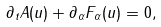<formula> <loc_0><loc_0><loc_500><loc_500>\partial _ { t } A ( u ) + \partial _ { \alpha } F _ { \alpha } ( u ) = 0 ,</formula> 